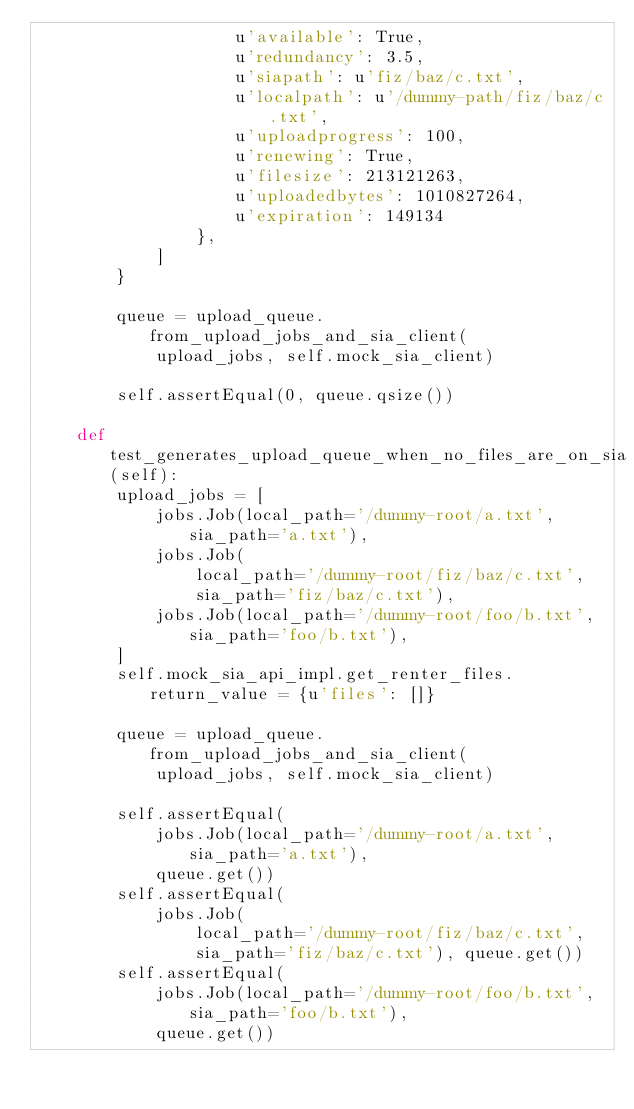<code> <loc_0><loc_0><loc_500><loc_500><_Python_>                    u'available': True,
                    u'redundancy': 3.5,
                    u'siapath': u'fiz/baz/c.txt',
                    u'localpath': u'/dummy-path/fiz/baz/c.txt',
                    u'uploadprogress': 100,
                    u'renewing': True,
                    u'filesize': 213121263,
                    u'uploadedbytes': 1010827264,
                    u'expiration': 149134
                },
            ]
        }

        queue = upload_queue.from_upload_jobs_and_sia_client(
            upload_jobs, self.mock_sia_client)

        self.assertEqual(0, queue.qsize())

    def test_generates_upload_queue_when_no_files_are_on_sia(self):
        upload_jobs = [
            jobs.Job(local_path='/dummy-root/a.txt', sia_path='a.txt'),
            jobs.Job(
                local_path='/dummy-root/fiz/baz/c.txt',
                sia_path='fiz/baz/c.txt'),
            jobs.Job(local_path='/dummy-root/foo/b.txt', sia_path='foo/b.txt'),
        ]
        self.mock_sia_api_impl.get_renter_files.return_value = {u'files': []}

        queue = upload_queue.from_upload_jobs_and_sia_client(
            upload_jobs, self.mock_sia_client)

        self.assertEqual(
            jobs.Job(local_path='/dummy-root/a.txt', sia_path='a.txt'),
            queue.get())
        self.assertEqual(
            jobs.Job(
                local_path='/dummy-root/fiz/baz/c.txt',
                sia_path='fiz/baz/c.txt'), queue.get())
        self.assertEqual(
            jobs.Job(local_path='/dummy-root/foo/b.txt', sia_path='foo/b.txt'),
            queue.get())
</code> 